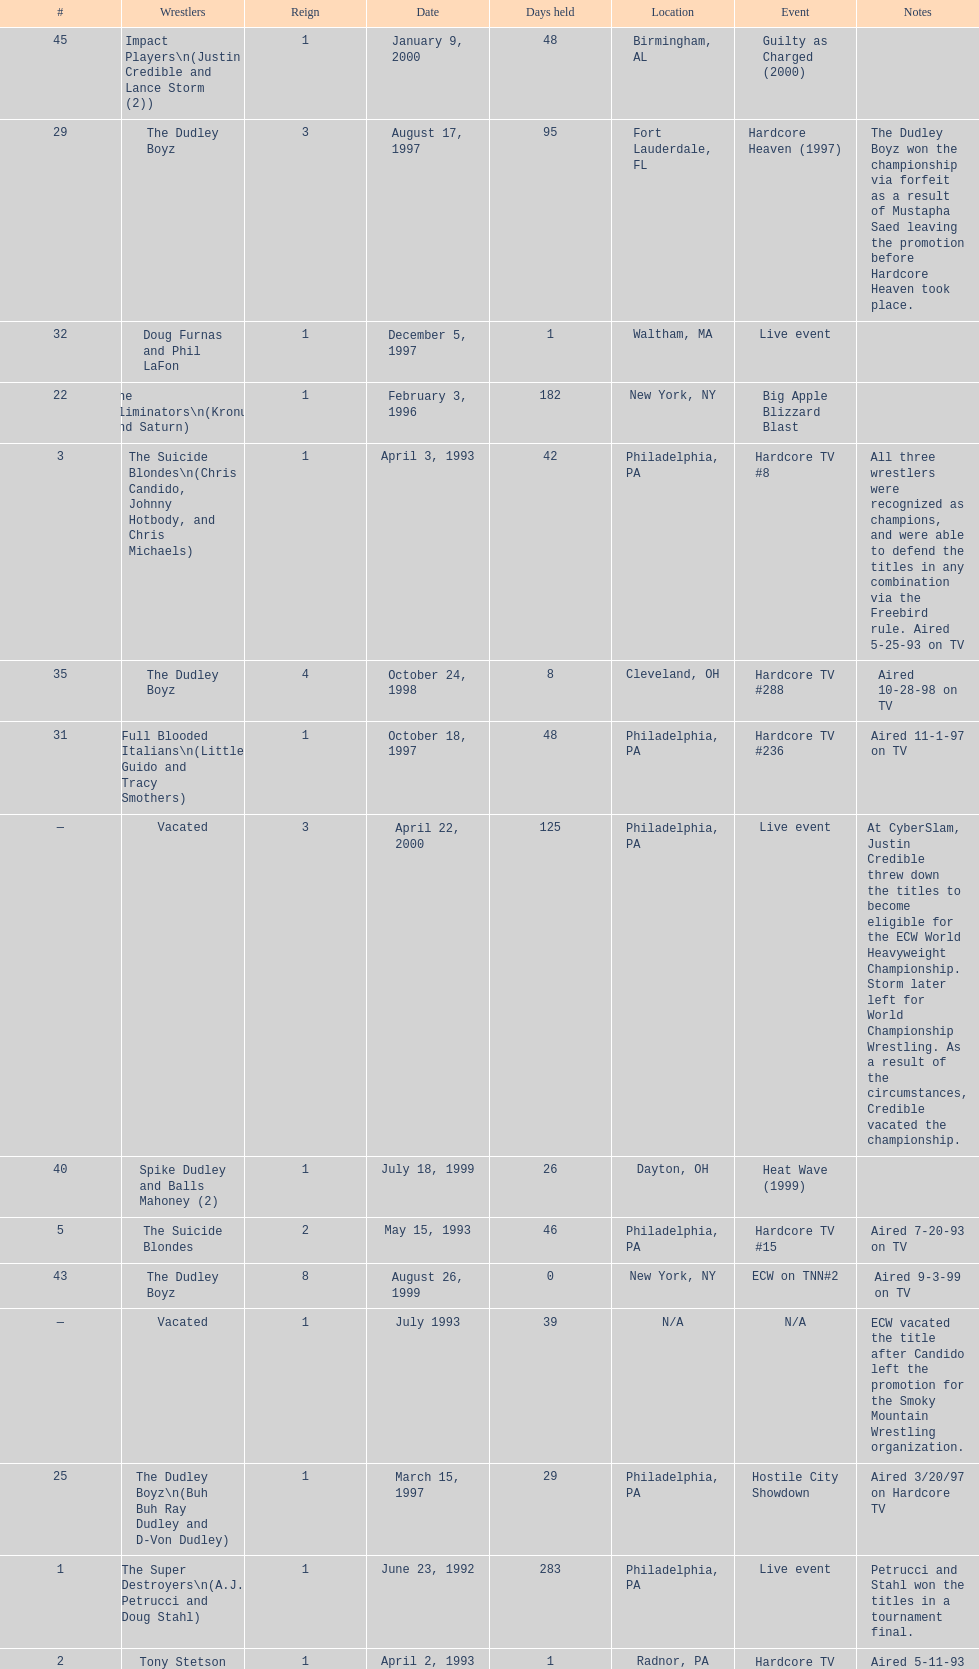What is the next event after hardcore tv #15? Hardcore TV #21. 